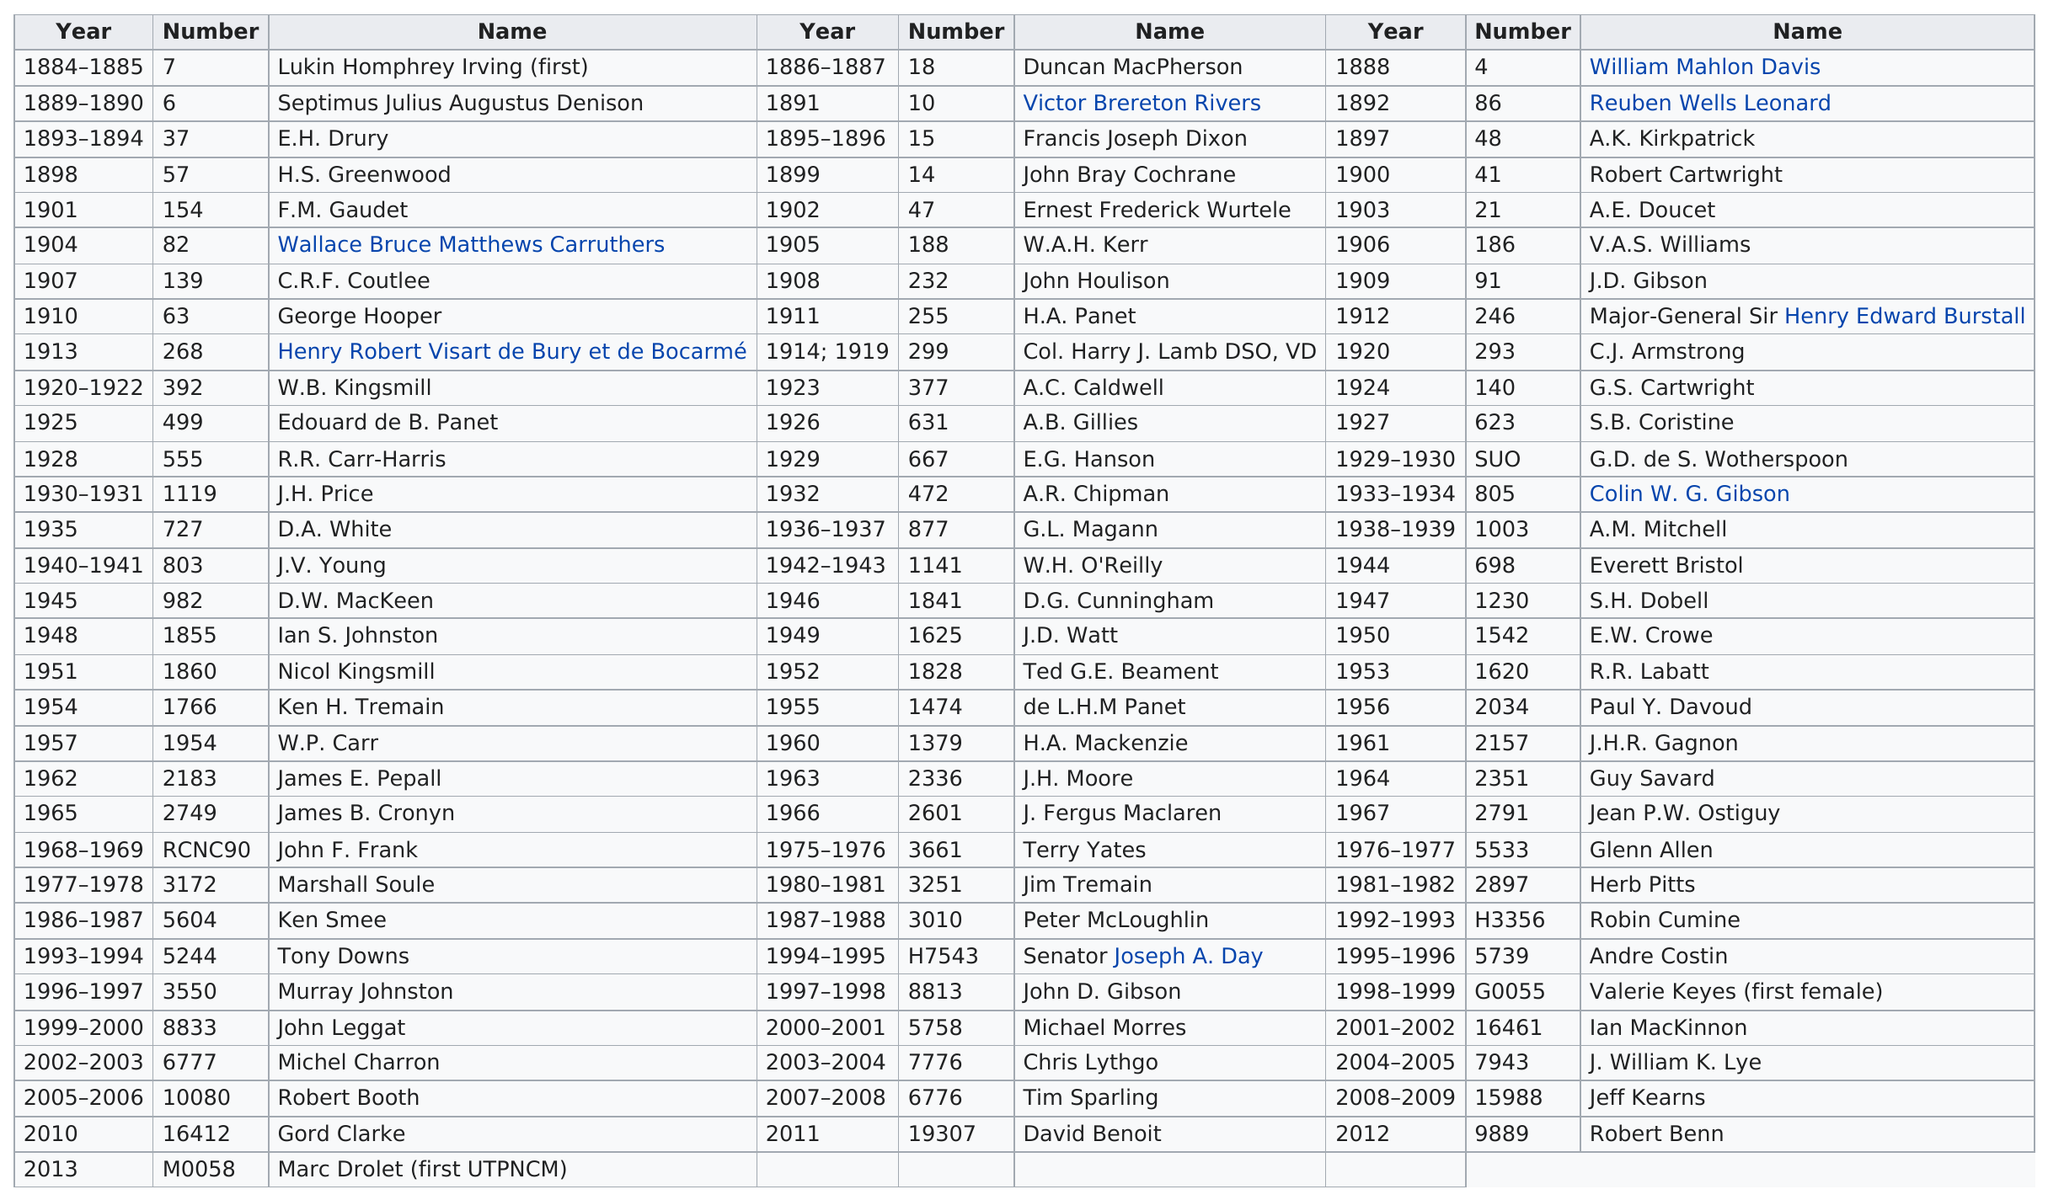Outline some significant characteristics in this image. Lukin Homphrey Irving was the first president of RMC Club. W.B. Kingsmill was the club president who held his position for the longest period of time. Barbara Kingsmill served as the president of the club for a period of two years. It is known that Robert Cartwright was the first president of the RMC Club in the 20th century. Four club presidents held their position in the 19th century. 